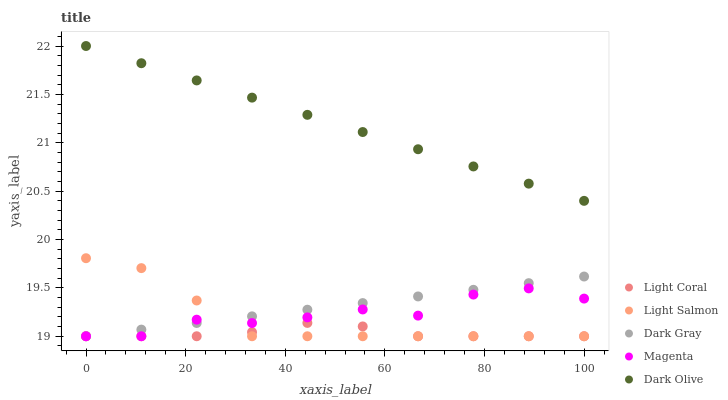Does Light Coral have the minimum area under the curve?
Answer yes or no. Yes. Does Dark Olive have the maximum area under the curve?
Answer yes or no. Yes. Does Dark Gray have the minimum area under the curve?
Answer yes or no. No. Does Dark Gray have the maximum area under the curve?
Answer yes or no. No. Is Dark Olive the smoothest?
Answer yes or no. Yes. Is Magenta the roughest?
Answer yes or no. Yes. Is Dark Gray the smoothest?
Answer yes or no. No. Is Dark Gray the roughest?
Answer yes or no. No. Does Light Coral have the lowest value?
Answer yes or no. Yes. Does Dark Olive have the lowest value?
Answer yes or no. No. Does Dark Olive have the highest value?
Answer yes or no. Yes. Does Dark Gray have the highest value?
Answer yes or no. No. Is Dark Gray less than Dark Olive?
Answer yes or no. Yes. Is Dark Olive greater than Magenta?
Answer yes or no. Yes. Does Light Salmon intersect Dark Gray?
Answer yes or no. Yes. Is Light Salmon less than Dark Gray?
Answer yes or no. No. Is Light Salmon greater than Dark Gray?
Answer yes or no. No. Does Dark Gray intersect Dark Olive?
Answer yes or no. No. 